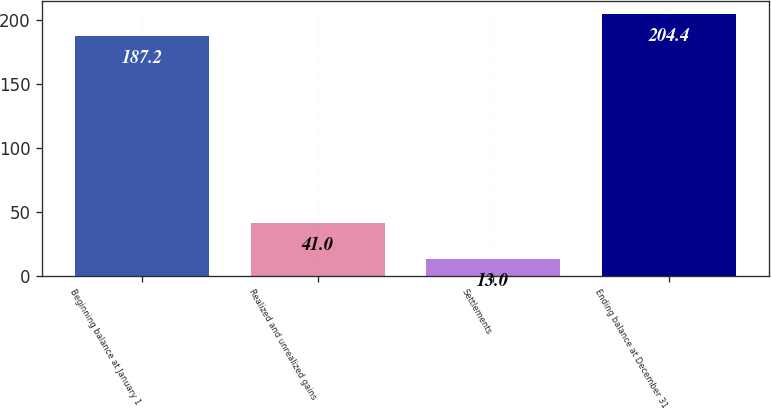Convert chart. <chart><loc_0><loc_0><loc_500><loc_500><bar_chart><fcel>Beginning balance at January 1<fcel>Realized and unrealized gains<fcel>Settlements<fcel>Ending balance at December 31<nl><fcel>187.2<fcel>41<fcel>13<fcel>204.4<nl></chart> 